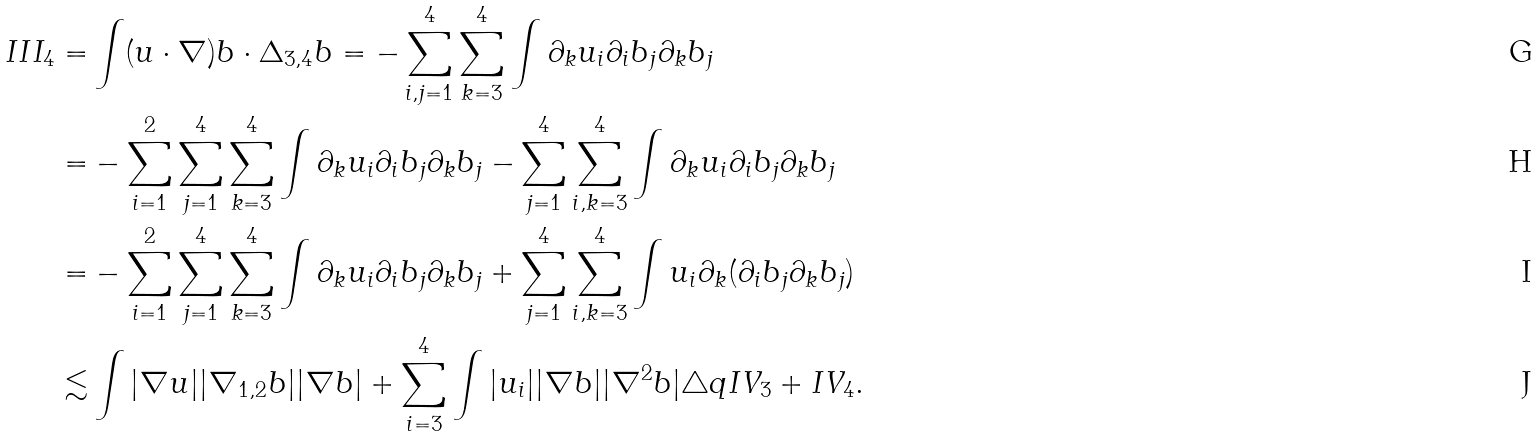<formula> <loc_0><loc_0><loc_500><loc_500>I I I _ { 4 } = & \int ( u \cdot \nabla ) b \cdot \Delta _ { 3 , 4 } b = - \sum _ { i , j = 1 } ^ { 4 } \sum _ { k = 3 } ^ { 4 } \int \partial _ { k } u _ { i } \partial _ { i } b _ { j } \partial _ { k } b _ { j } \\ = & - \sum _ { i = 1 } ^ { 2 } \sum _ { j = 1 } ^ { 4 } \sum _ { k = 3 } ^ { 4 } \int \partial _ { k } u _ { i } \partial _ { i } b _ { j } \partial _ { k } b _ { j } - \sum _ { j = 1 } ^ { 4 } \sum _ { i , k = 3 } ^ { 4 } \int \partial _ { k } u _ { i } \partial _ { i } b _ { j } \partial _ { k } b _ { j } \\ = & - \sum _ { i = 1 } ^ { 2 } \sum _ { j = 1 } ^ { 4 } \sum _ { k = 3 } ^ { 4 } \int \partial _ { k } u _ { i } \partial _ { i } b _ { j } \partial _ { k } b _ { j } + \sum _ { j = 1 } ^ { 4 } \sum _ { i , k = 3 } ^ { 4 } \int u _ { i } \partial _ { k } ( \partial _ { i } b _ { j } \partial _ { k } b _ { j } ) \\ \lesssim & \int | \nabla u | | \nabla _ { 1 , 2 } b | | \nabla b | + \sum _ { i = 3 } ^ { 4 } \int | u _ { i } | | \nabla b | | \nabla ^ { 2 } b | \triangle q I V _ { 3 } + I V _ { 4 } .</formula> 